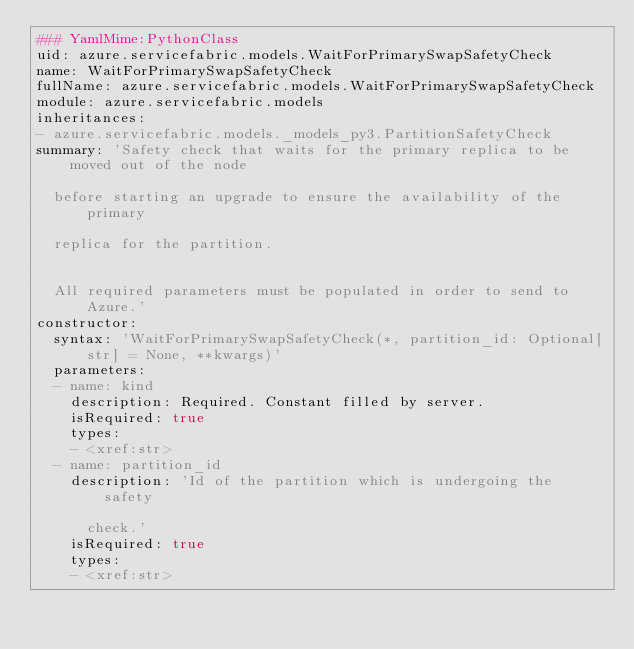Convert code to text. <code><loc_0><loc_0><loc_500><loc_500><_YAML_>### YamlMime:PythonClass
uid: azure.servicefabric.models.WaitForPrimarySwapSafetyCheck
name: WaitForPrimarySwapSafetyCheck
fullName: azure.servicefabric.models.WaitForPrimarySwapSafetyCheck
module: azure.servicefabric.models
inheritances:
- azure.servicefabric.models._models_py3.PartitionSafetyCheck
summary: 'Safety check that waits for the primary replica to be moved out of the node

  before starting an upgrade to ensure the availability of the primary

  replica for the partition.


  All required parameters must be populated in order to send to Azure.'
constructor:
  syntax: 'WaitForPrimarySwapSafetyCheck(*, partition_id: Optional[str] = None, **kwargs)'
  parameters:
  - name: kind
    description: Required. Constant filled by server.
    isRequired: true
    types:
    - <xref:str>
  - name: partition_id
    description: 'Id of the partition which is undergoing the safety

      check.'
    isRequired: true
    types:
    - <xref:str>
</code> 